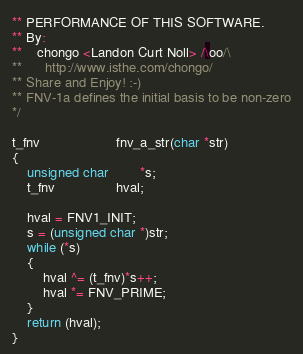Convert code to text. <code><loc_0><loc_0><loc_500><loc_500><_C_>** PERFORMANCE OF THIS SOFTWARE.
** By:
**	chongo <Landon Curt Noll> /\oo/\
**      http://www.isthe.com/chongo/
** Share and Enjoy!	:-)
** FNV-1a defines the initial basis to be non-zero
*/

t_fnv					fnv_a_str(char *str)
{
	unsigned char		*s;
	t_fnv				hval;

	hval = FNV1_INIT;
	s = (unsigned char *)str;
	while (*s)
	{
		hval ^= (t_fnv)*s++;
		hval *= FNV_PRIME;
	}
	return (hval);
}
</code> 